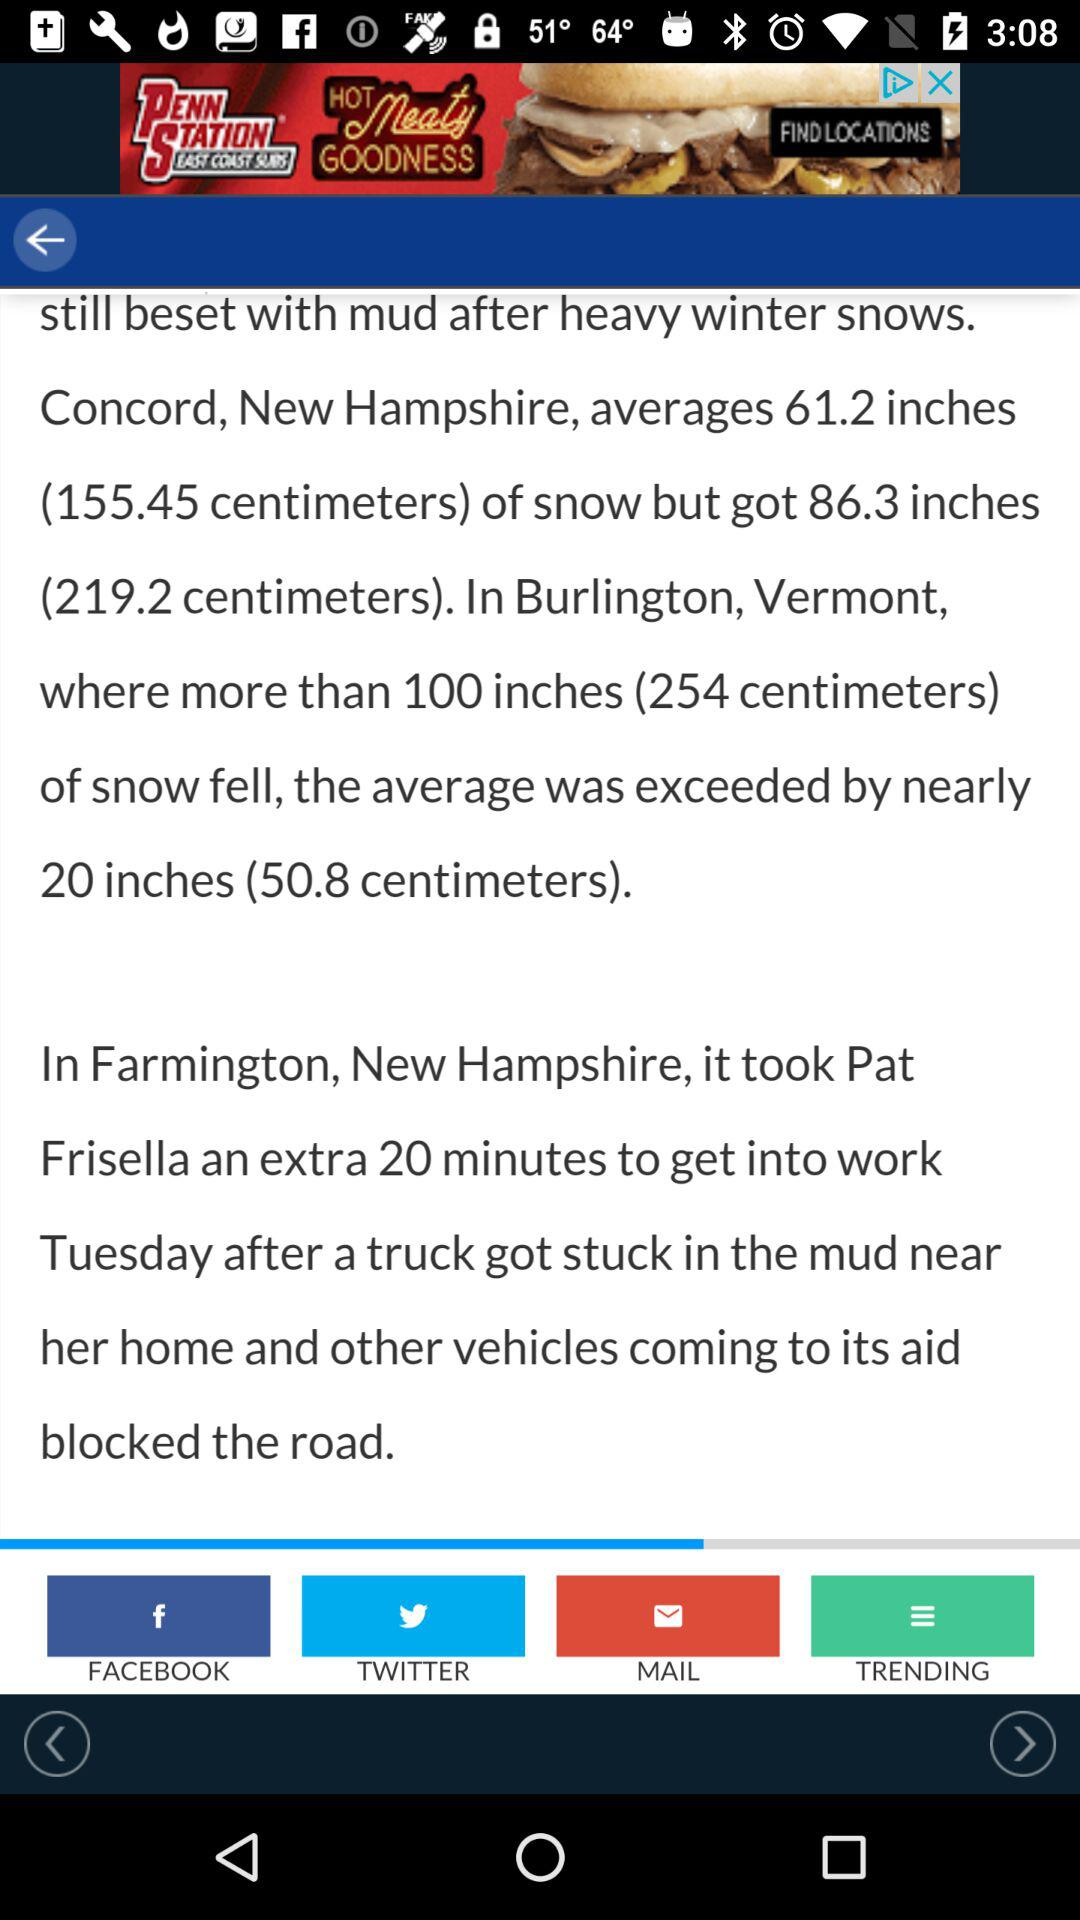How many degrees Fahrenheit is the difference between the current temperature and the low temperature for today?
Answer the question using a single word or phrase. 24 